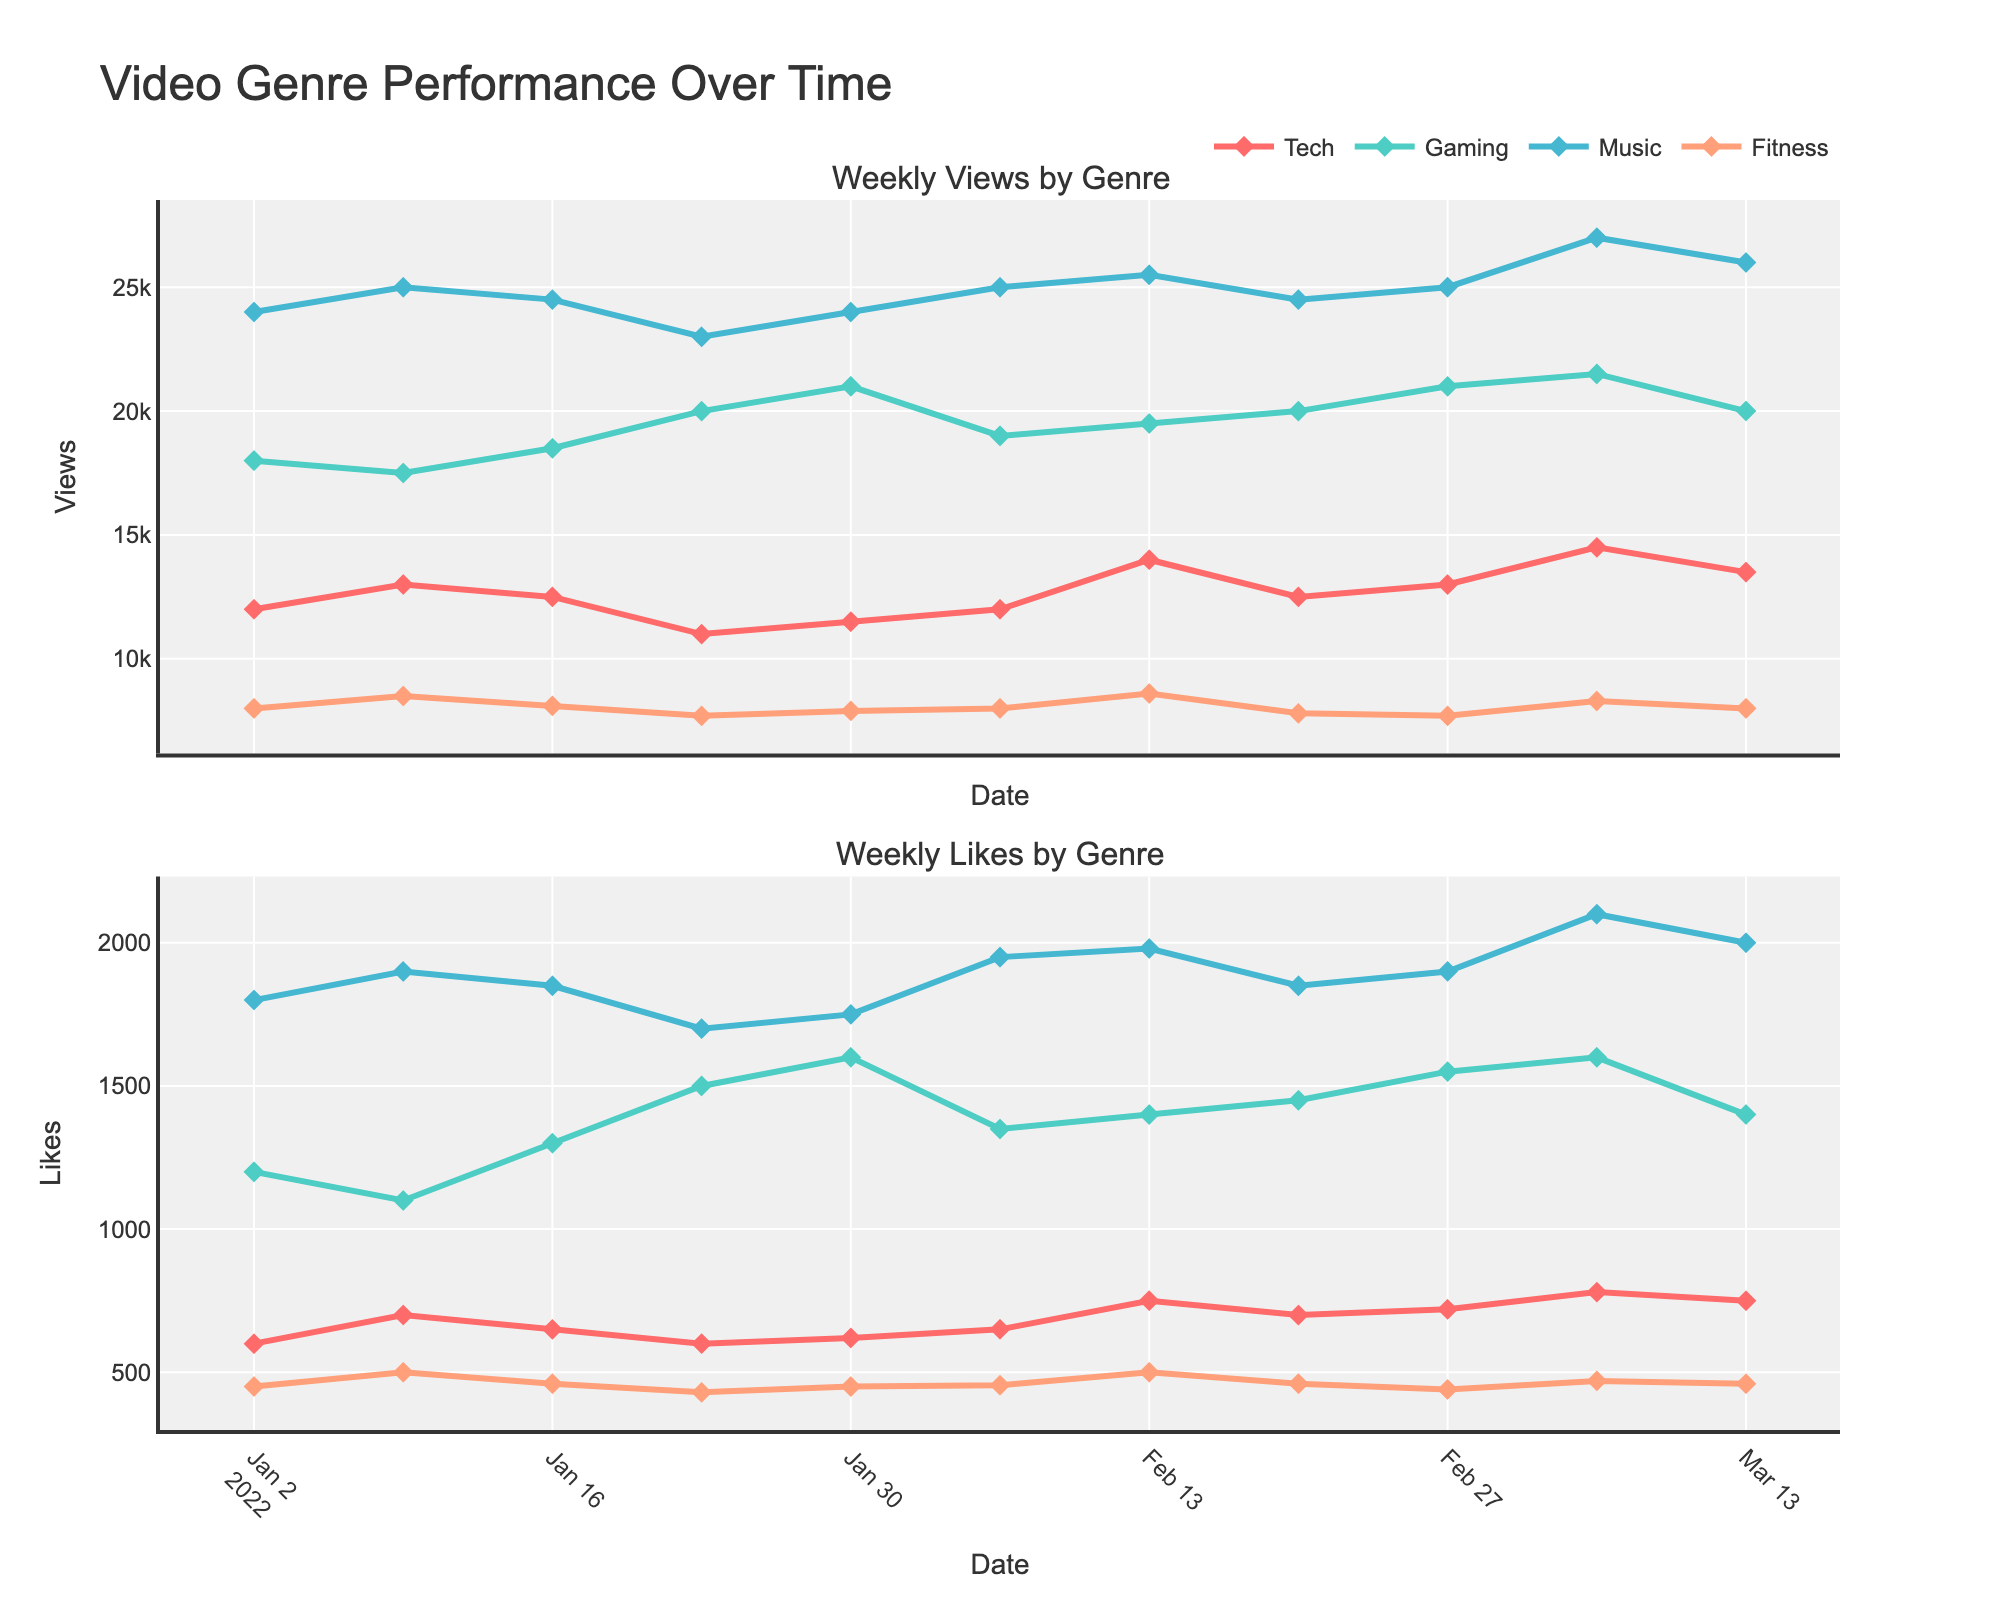What are the titles of the two subplots? The titles of subplots can be found at the top of each plot panel within the figure. For this figure, the titles are "Weekly Views by Genre" for the upper plot and "Weekly Likes by Genre" for the lower plot.
Answer: "Weekly Views by Genre" and "Weekly Likes by Genre" Which genre had the most views on January 9, 2022? To find the genre with the most views on January 9, 2022, we look at the data points in the upper plot for that specific date. The highest value corresponds to the genre "Music".
Answer: Music What was the trend for views in the "Gaming" genre over the first five weeks? To determine the trend, we trace the line representing the "Gaming" genre in the upper plot from the beginning to the end of the first five weeks. The values started at 18,000, decreased slightly to 17,500, then increased to 18,500, 20,000, and 21,000. The overall trend is an increase.
Answer: Increasing Compare the views and likes for the "Fitness" genre on February 13, 2022. Are the trends the same? By locating the data points in both subplots for the "Fitness" genre on February 13, 2022, we see that views increased to 8,600 and likes increased to 500. Both metrics show an increasing trend compared to previous weeks.
Answer: Yes What color represents the "Tech" genre in the figure? The genre's representation can be identified by looking at the line colors in the legend. The line and markers for "Tech" are colored red.
Answer: Red Which week did the "Music" genre reach 27,000 views, and what was the number of likes then? By examining the upper plot, we find that on March 6, 2022, the "Music" genre hit 27,000 views. Checking the corresponding data point on the lower plot for likes, we see it reached 2,100 likes.
Answer: March 6, 2022, 2,100 likes How much did the "Tech" genre's views increase from February 6 to February 13, 2022? First, find the views on both dates in the upper plot. On February 6, 2022, views were 12,000. On February 13, 2022, views were 14,000. The difference is 14,000 - 12,000 = 2,000 views.
Answer: 2,000 views Between "Gaming" and "Fitness", which had the higher increase in likes from January 16 to January 23, 2022? For "Gaming", likes increased from 1,300 to 1,500, a difference of 200. For "Fitness", likes decreased from 460 to 430, a difference of -30. The "Gaming" genre had the higher increase in likes.
Answer: Gaming 